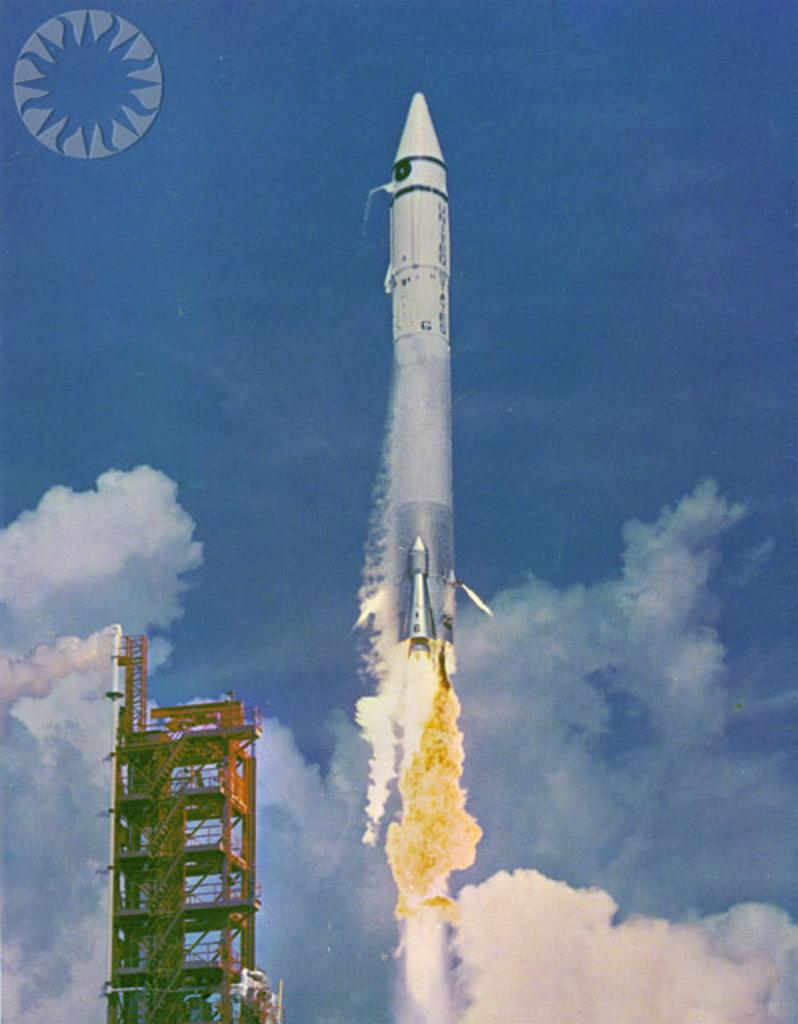What is the main subject of the image? The main subject of the image is a rocket. What can be observed about the rocket in the image? The rocket has fire and smoke in the image. What other structures are present in the image? There is a tower in the image. Is there any text or symbol in the image? Yes, there is an emblem in the left top corner of the image. What is visible in the background of the image? The sky is visible in the background of the image. How does the tiger interact with the rocket in the image? There is no tiger present in the image, so it cannot interact with the rocket. What is the edge of the rocket made of in the image? The facts provided do not specify the material of the rocket's edge, so we cannot definitively answer this question. 